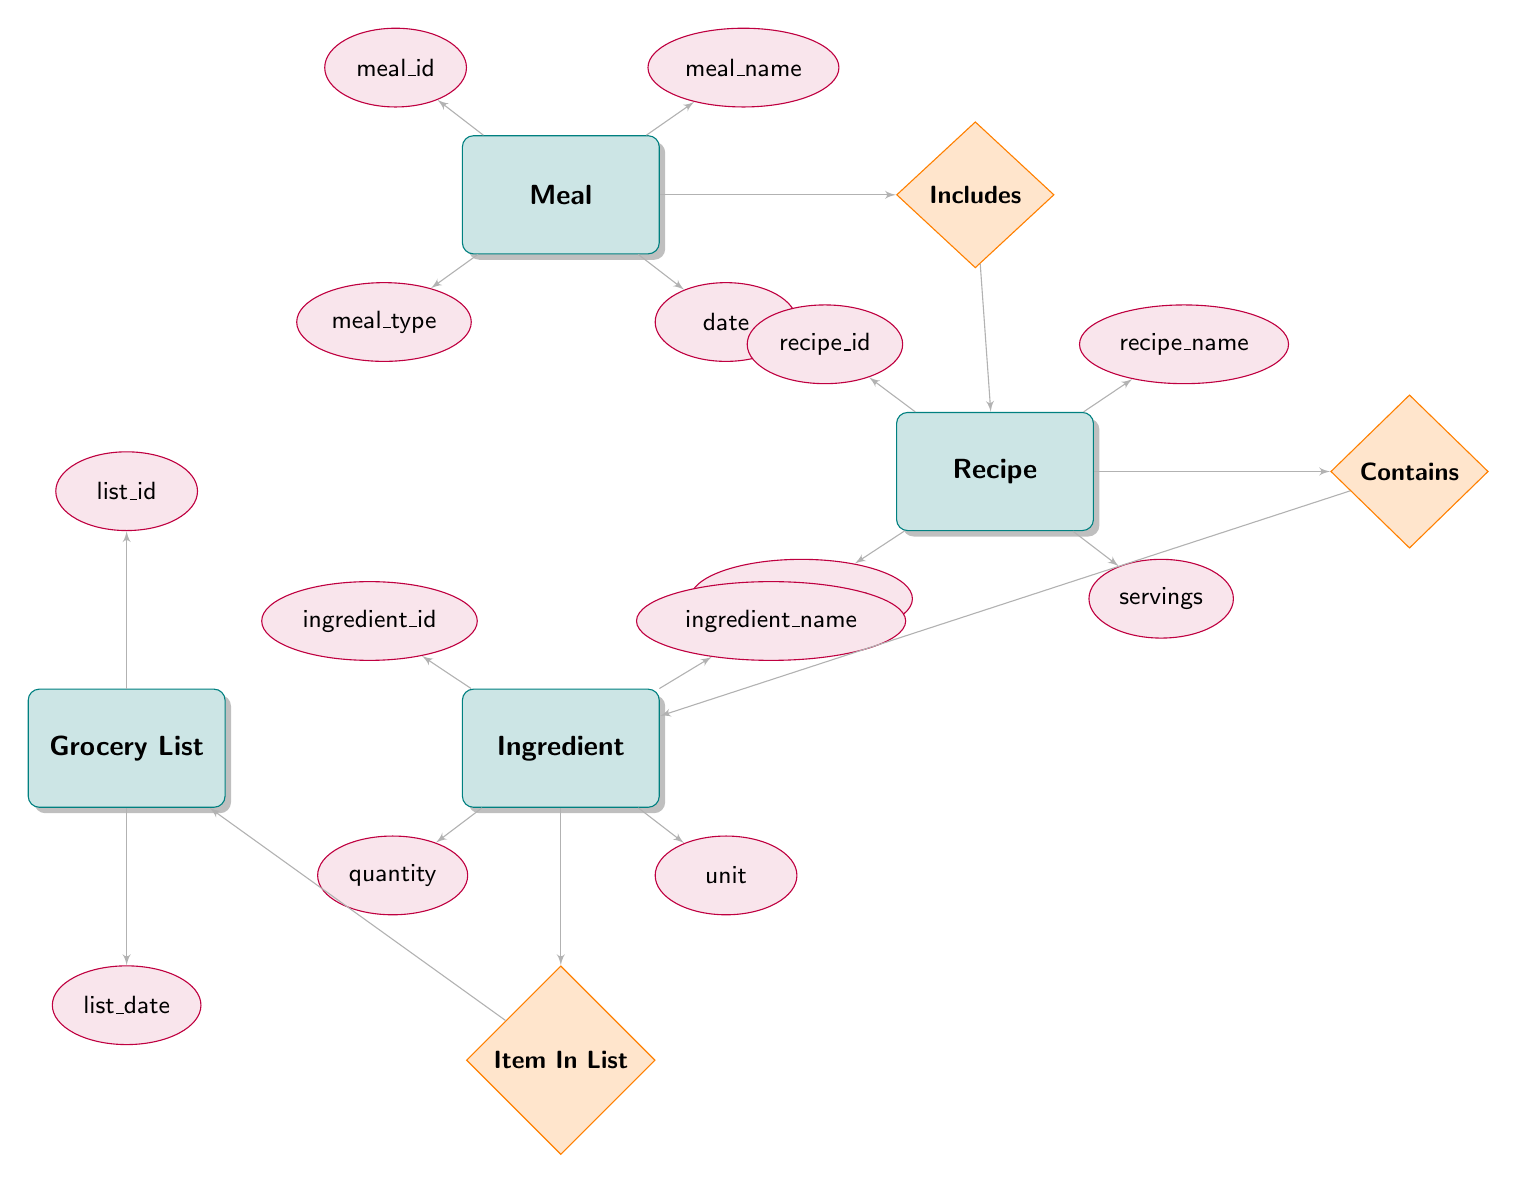What are the attributes of the Meal entity? The Meal entity has four attributes: meal_id, meal_name, meal_type, and date. These attributes are listed directly around the Meal node in the diagram.
Answer: meal_id, meal_name, meal_type, date How many entities are in the diagram? There are four entities depicted in the diagram: Meal, Recipe, Ingredient, and Grocery List. The entities can be counted directly from the diagram's structure.
Answer: 4 What relationship connects Meal and Recipe? The Includes relationship connects Meal and Recipe. This relationship can be identified by following the arrow connecting the Meal entity to the Recipe entity, which is labeled with the term "Includes."
Answer: Includes Which entity contains a list of ingredients? The Recipe entity contains a list of ingredients. This can be inferred by looking at the Contains relationship that flows from Recipe to Ingredient.
Answer: Recipe What is the main purpose of the Grocery List in the diagram? The Grocery List serves as a container for ingredients needed for meals. This is evident from the Item In List relationship that connects Grocery List to Ingredient.
Answer: Container for ingredients How many attributes does the Recipe entity have? The Recipe entity has four attributes: recipe_id, recipe_name, cooking_time, and servings. Counting these attributes leads to the answer.
Answer: 4 What is the connection between Recipe and Ingredient entities? The connection is defined by the Contains relationship. This is indicated by the arrow leading from the Recipe entity to the Ingredient entity, which is labeled as "Contains."
Answer: Contains How many relationships are there in total? There are three relationships in the diagram: Includes, Contains, and Item In List. Counting these relationships gives the total number.
Answer: 3 What attribute represents the quantity of an ingredient? The attribute that represents the quantity of an ingredient is "quantity." This attribute is specifically tied to the Ingredient entity in the diagram.
Answer: quantity 